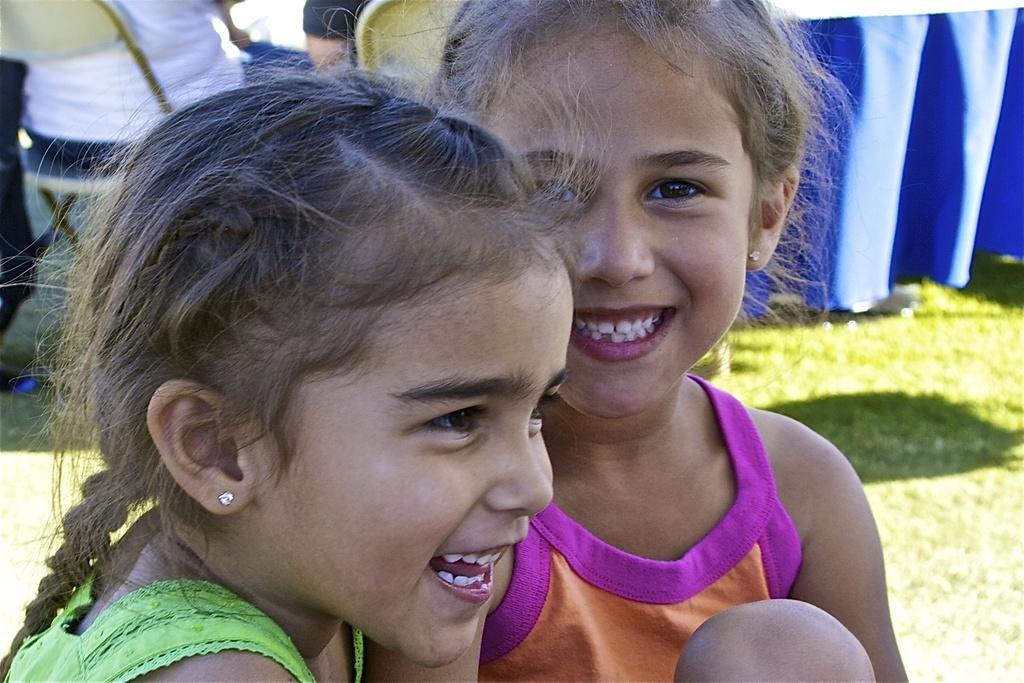Can you describe this image briefly? In the middle of this image, there are two child girls in different colored dresses, smiling. In the background, there is a blue colored cloth, there are two persons sitting on chairs and there is grass on the ground. 